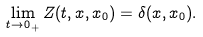Convert formula to latex. <formula><loc_0><loc_0><loc_500><loc_500>\lim _ { t \rightarrow 0 _ { + } } Z ( t , x , x _ { 0 } ) = \delta ( x , x _ { 0 } ) .</formula> 